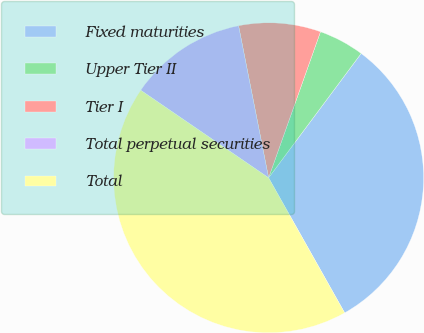<chart> <loc_0><loc_0><loc_500><loc_500><pie_chart><fcel>Fixed maturities<fcel>Upper Tier II<fcel>Tier I<fcel>Total perpetual securities<fcel>Total<nl><fcel>31.65%<fcel>4.75%<fcel>8.54%<fcel>12.34%<fcel>42.72%<nl></chart> 